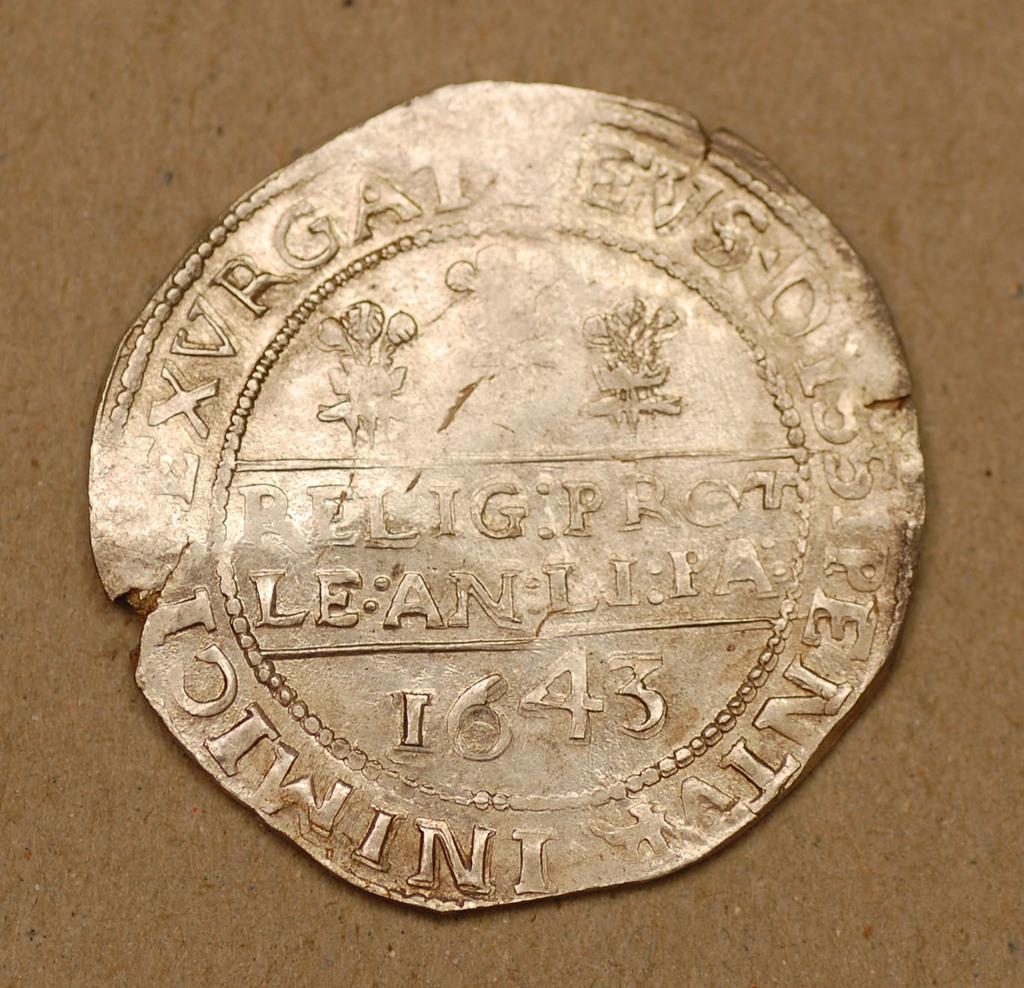In one or two sentences, can you explain what this image depicts? In this image we can see a coin with numbers and letters engraved on it. 